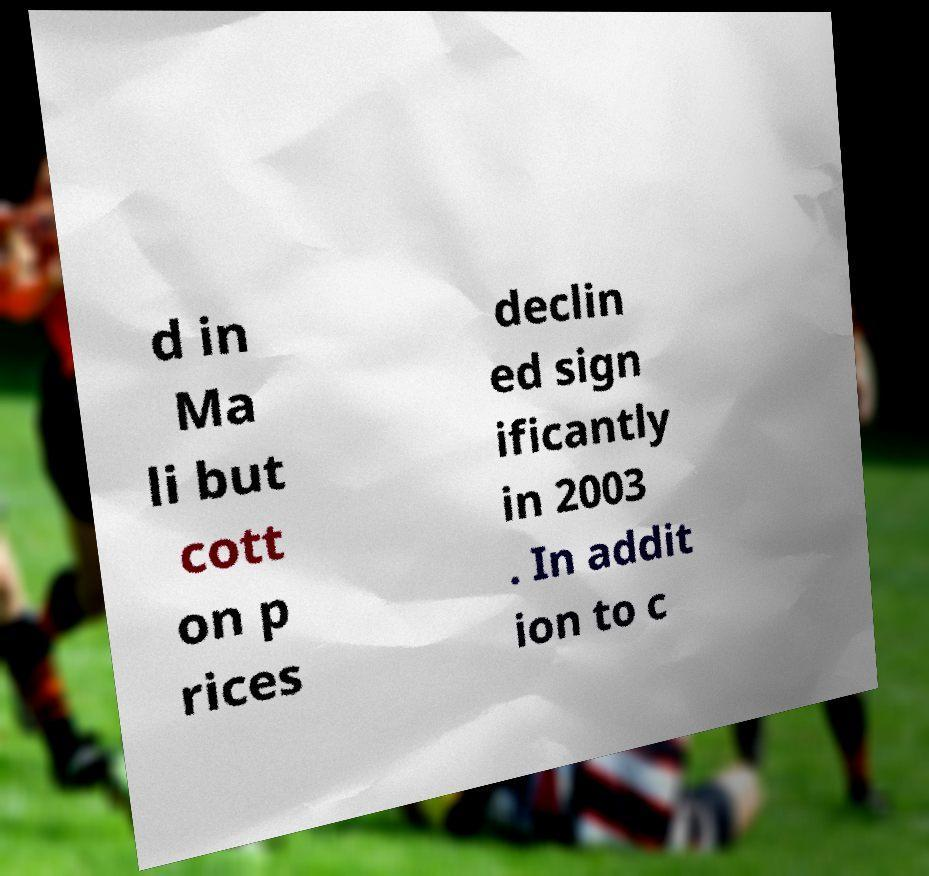I need the written content from this picture converted into text. Can you do that? d in Ma li but cott on p rices declin ed sign ificantly in 2003 . In addit ion to c 